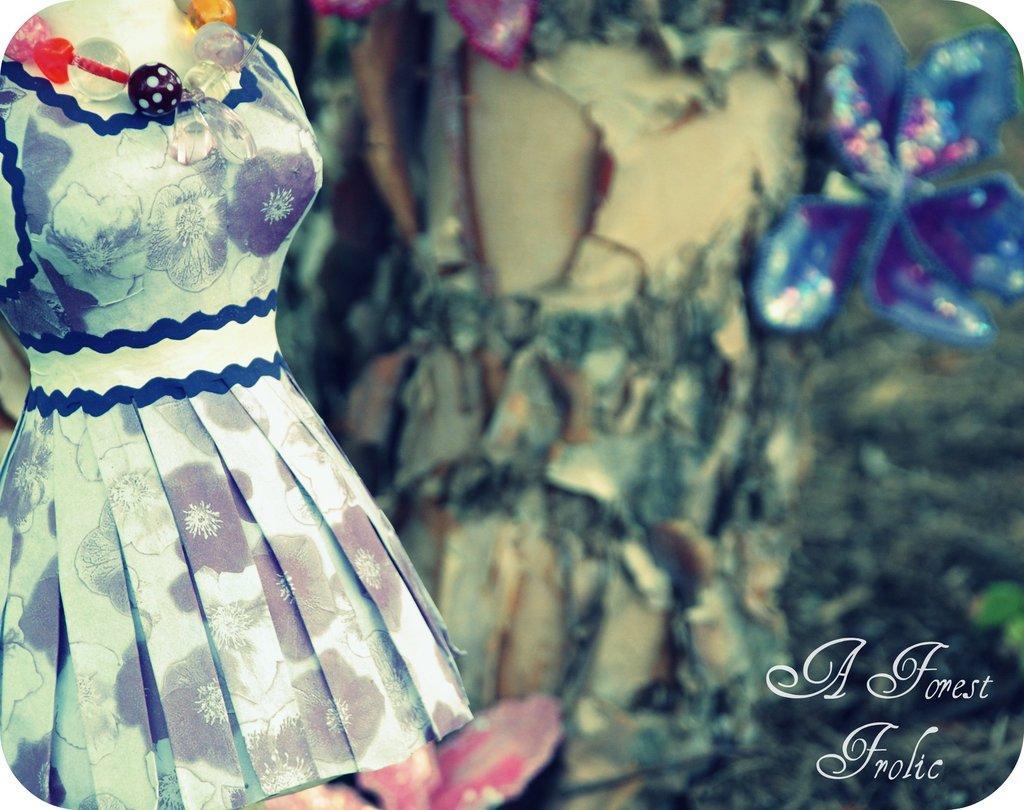Could you give a brief overview of what you see in this image? This is an edited image. On the left we can see a mannequin wearing a frock and a necklace. In the background we can see there are some other objects. In the bottom right corner we can see the text on the image. 